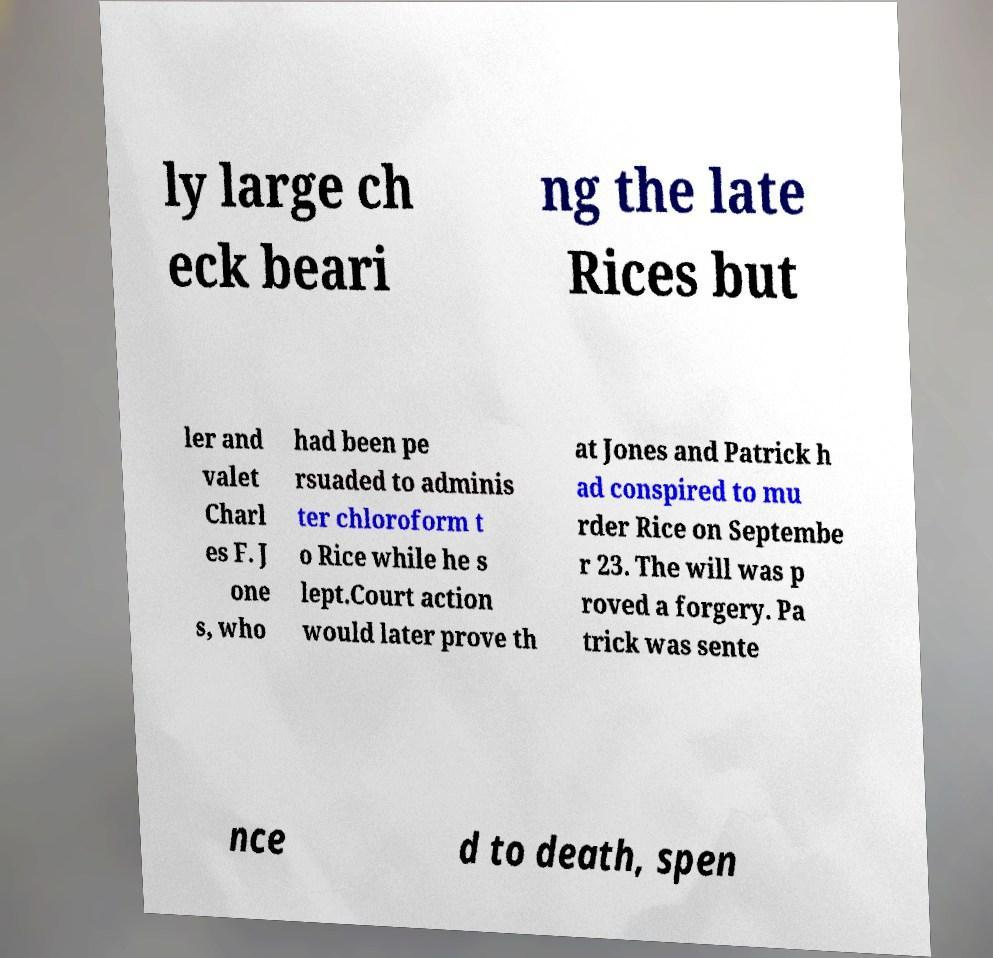There's text embedded in this image that I need extracted. Can you transcribe it verbatim? ly large ch eck beari ng the late Rices but ler and valet Charl es F. J one s, who had been pe rsuaded to adminis ter chloroform t o Rice while he s lept.Court action would later prove th at Jones and Patrick h ad conspired to mu rder Rice on Septembe r 23. The will was p roved a forgery. Pa trick was sente nce d to death, spen 